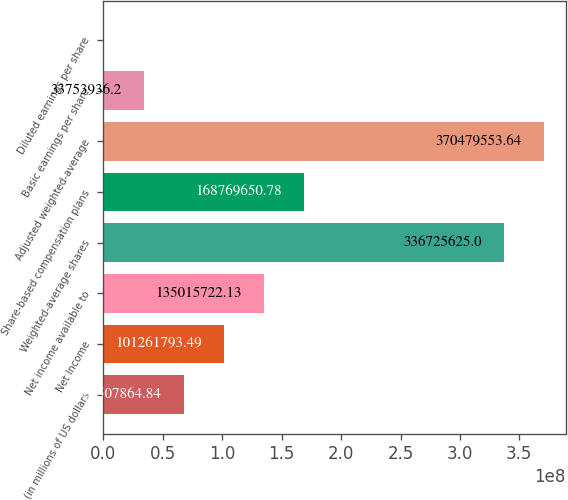<chart> <loc_0><loc_0><loc_500><loc_500><bar_chart><fcel>(in millions of US dollars<fcel>Net Income<fcel>Net income available to<fcel>Weighted-average shares<fcel>Share-based compensation plans<fcel>Adjusted weighted-average<fcel>Basic earnings per share<fcel>Diluted earnings per share<nl><fcel>6.75079e+07<fcel>1.01262e+08<fcel>1.35016e+08<fcel>3.36726e+08<fcel>1.6877e+08<fcel>3.7048e+08<fcel>3.37539e+07<fcel>7.55<nl></chart> 